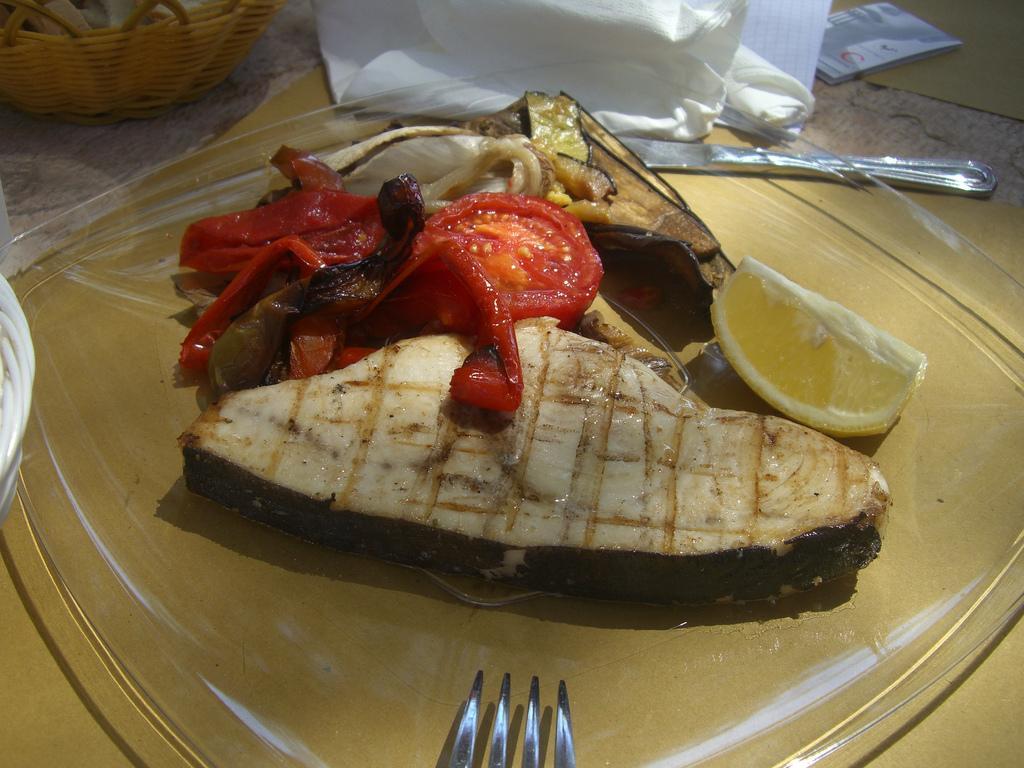How would you summarize this image in a sentence or two? In this image there is a glass plate on which there is some food stuff and a lemon piece beside it. At the top there is a basket. Beside the basket there is a tissue paper. At the bottom there is a fork. On the right side top there is a spoon. 